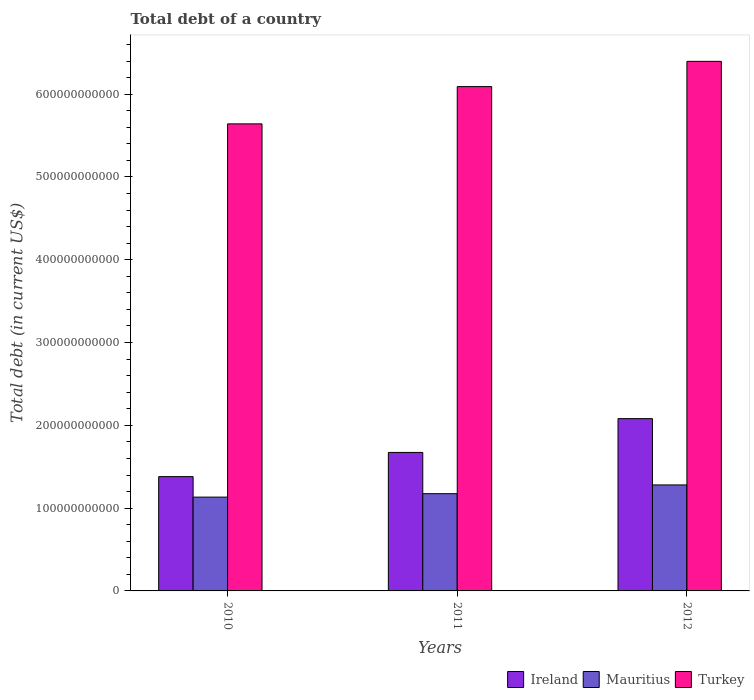How many different coloured bars are there?
Your response must be concise. 3. How many groups of bars are there?
Give a very brief answer. 3. Are the number of bars per tick equal to the number of legend labels?
Make the answer very short. Yes. What is the debt in Mauritius in 2010?
Your answer should be compact. 1.13e+11. Across all years, what is the maximum debt in Turkey?
Your answer should be compact. 6.40e+11. Across all years, what is the minimum debt in Turkey?
Make the answer very short. 5.64e+11. In which year was the debt in Mauritius maximum?
Give a very brief answer. 2012. What is the total debt in Ireland in the graph?
Make the answer very short. 5.13e+11. What is the difference between the debt in Mauritius in 2011 and that in 2012?
Keep it short and to the point. -1.06e+1. What is the difference between the debt in Ireland in 2011 and the debt in Mauritius in 2012?
Make the answer very short. 3.93e+1. What is the average debt in Turkey per year?
Your answer should be very brief. 6.04e+11. In the year 2010, what is the difference between the debt in Turkey and debt in Ireland?
Offer a terse response. 4.26e+11. In how many years, is the debt in Turkey greater than 500000000000 US$?
Provide a short and direct response. 3. What is the ratio of the debt in Turkey in 2010 to that in 2011?
Give a very brief answer. 0.93. Is the difference between the debt in Turkey in 2011 and 2012 greater than the difference between the debt in Ireland in 2011 and 2012?
Offer a terse response. Yes. What is the difference between the highest and the second highest debt in Mauritius?
Give a very brief answer. 1.06e+1. What is the difference between the highest and the lowest debt in Turkey?
Provide a short and direct response. 7.55e+1. What does the 2nd bar from the right in 2012 represents?
Ensure brevity in your answer.  Mauritius. Is it the case that in every year, the sum of the debt in Turkey and debt in Ireland is greater than the debt in Mauritius?
Make the answer very short. Yes. How many bars are there?
Give a very brief answer. 9. Are all the bars in the graph horizontal?
Your answer should be very brief. No. What is the difference between two consecutive major ticks on the Y-axis?
Your response must be concise. 1.00e+11. Are the values on the major ticks of Y-axis written in scientific E-notation?
Make the answer very short. No. Does the graph contain any zero values?
Offer a terse response. No. Where does the legend appear in the graph?
Ensure brevity in your answer.  Bottom right. How many legend labels are there?
Your response must be concise. 3. How are the legend labels stacked?
Give a very brief answer. Horizontal. What is the title of the graph?
Offer a very short reply. Total debt of a country. Does "Panama" appear as one of the legend labels in the graph?
Give a very brief answer. No. What is the label or title of the Y-axis?
Your answer should be compact. Total debt (in current US$). What is the Total debt (in current US$) in Ireland in 2010?
Ensure brevity in your answer.  1.38e+11. What is the Total debt (in current US$) of Mauritius in 2010?
Keep it short and to the point. 1.13e+11. What is the Total debt (in current US$) in Turkey in 2010?
Keep it short and to the point. 5.64e+11. What is the Total debt (in current US$) in Ireland in 2011?
Your answer should be very brief. 1.67e+11. What is the Total debt (in current US$) in Mauritius in 2011?
Ensure brevity in your answer.  1.17e+11. What is the Total debt (in current US$) in Turkey in 2011?
Your response must be concise. 6.09e+11. What is the Total debt (in current US$) in Ireland in 2012?
Keep it short and to the point. 2.08e+11. What is the Total debt (in current US$) in Mauritius in 2012?
Offer a terse response. 1.28e+11. What is the Total debt (in current US$) of Turkey in 2012?
Offer a very short reply. 6.40e+11. Across all years, what is the maximum Total debt (in current US$) of Ireland?
Make the answer very short. 2.08e+11. Across all years, what is the maximum Total debt (in current US$) of Mauritius?
Make the answer very short. 1.28e+11. Across all years, what is the maximum Total debt (in current US$) in Turkey?
Offer a terse response. 6.40e+11. Across all years, what is the minimum Total debt (in current US$) in Ireland?
Your answer should be compact. 1.38e+11. Across all years, what is the minimum Total debt (in current US$) in Mauritius?
Make the answer very short. 1.13e+11. Across all years, what is the minimum Total debt (in current US$) in Turkey?
Your answer should be compact. 5.64e+11. What is the total Total debt (in current US$) in Ireland in the graph?
Provide a succinct answer. 5.13e+11. What is the total Total debt (in current US$) of Mauritius in the graph?
Offer a terse response. 3.59e+11. What is the total Total debt (in current US$) in Turkey in the graph?
Offer a terse response. 1.81e+12. What is the difference between the Total debt (in current US$) in Ireland in 2010 and that in 2011?
Your answer should be very brief. -2.92e+1. What is the difference between the Total debt (in current US$) of Mauritius in 2010 and that in 2011?
Provide a succinct answer. -4.16e+09. What is the difference between the Total debt (in current US$) in Turkey in 2010 and that in 2011?
Keep it short and to the point. -4.50e+1. What is the difference between the Total debt (in current US$) in Ireland in 2010 and that in 2012?
Provide a short and direct response. -7.00e+1. What is the difference between the Total debt (in current US$) in Mauritius in 2010 and that in 2012?
Offer a terse response. -1.47e+1. What is the difference between the Total debt (in current US$) of Turkey in 2010 and that in 2012?
Provide a succinct answer. -7.55e+1. What is the difference between the Total debt (in current US$) of Ireland in 2011 and that in 2012?
Your response must be concise. -4.08e+1. What is the difference between the Total debt (in current US$) of Mauritius in 2011 and that in 2012?
Offer a very short reply. -1.06e+1. What is the difference between the Total debt (in current US$) of Turkey in 2011 and that in 2012?
Make the answer very short. -3.05e+1. What is the difference between the Total debt (in current US$) in Ireland in 2010 and the Total debt (in current US$) in Mauritius in 2011?
Make the answer very short. 2.06e+1. What is the difference between the Total debt (in current US$) of Ireland in 2010 and the Total debt (in current US$) of Turkey in 2011?
Provide a succinct answer. -4.71e+11. What is the difference between the Total debt (in current US$) in Mauritius in 2010 and the Total debt (in current US$) in Turkey in 2011?
Make the answer very short. -4.96e+11. What is the difference between the Total debt (in current US$) in Ireland in 2010 and the Total debt (in current US$) in Mauritius in 2012?
Give a very brief answer. 1.00e+1. What is the difference between the Total debt (in current US$) of Ireland in 2010 and the Total debt (in current US$) of Turkey in 2012?
Offer a terse response. -5.02e+11. What is the difference between the Total debt (in current US$) of Mauritius in 2010 and the Total debt (in current US$) of Turkey in 2012?
Offer a terse response. -5.26e+11. What is the difference between the Total debt (in current US$) of Ireland in 2011 and the Total debt (in current US$) of Mauritius in 2012?
Your response must be concise. 3.93e+1. What is the difference between the Total debt (in current US$) in Ireland in 2011 and the Total debt (in current US$) in Turkey in 2012?
Your answer should be very brief. -4.72e+11. What is the difference between the Total debt (in current US$) in Mauritius in 2011 and the Total debt (in current US$) in Turkey in 2012?
Provide a succinct answer. -5.22e+11. What is the average Total debt (in current US$) in Ireland per year?
Give a very brief answer. 1.71e+11. What is the average Total debt (in current US$) in Mauritius per year?
Keep it short and to the point. 1.20e+11. What is the average Total debt (in current US$) of Turkey per year?
Provide a succinct answer. 6.04e+11. In the year 2010, what is the difference between the Total debt (in current US$) of Ireland and Total debt (in current US$) of Mauritius?
Ensure brevity in your answer.  2.48e+1. In the year 2010, what is the difference between the Total debt (in current US$) of Ireland and Total debt (in current US$) of Turkey?
Ensure brevity in your answer.  -4.26e+11. In the year 2010, what is the difference between the Total debt (in current US$) of Mauritius and Total debt (in current US$) of Turkey?
Your answer should be very brief. -4.51e+11. In the year 2011, what is the difference between the Total debt (in current US$) of Ireland and Total debt (in current US$) of Mauritius?
Your response must be concise. 4.98e+1. In the year 2011, what is the difference between the Total debt (in current US$) in Ireland and Total debt (in current US$) in Turkey?
Provide a succinct answer. -4.42e+11. In the year 2011, what is the difference between the Total debt (in current US$) in Mauritius and Total debt (in current US$) in Turkey?
Provide a succinct answer. -4.92e+11. In the year 2012, what is the difference between the Total debt (in current US$) in Ireland and Total debt (in current US$) in Mauritius?
Make the answer very short. 8.01e+1. In the year 2012, what is the difference between the Total debt (in current US$) in Ireland and Total debt (in current US$) in Turkey?
Provide a short and direct response. -4.32e+11. In the year 2012, what is the difference between the Total debt (in current US$) of Mauritius and Total debt (in current US$) of Turkey?
Your answer should be compact. -5.12e+11. What is the ratio of the Total debt (in current US$) of Ireland in 2010 to that in 2011?
Offer a very short reply. 0.83. What is the ratio of the Total debt (in current US$) in Mauritius in 2010 to that in 2011?
Provide a succinct answer. 0.96. What is the ratio of the Total debt (in current US$) in Turkey in 2010 to that in 2011?
Give a very brief answer. 0.93. What is the ratio of the Total debt (in current US$) in Ireland in 2010 to that in 2012?
Offer a terse response. 0.66. What is the ratio of the Total debt (in current US$) in Mauritius in 2010 to that in 2012?
Provide a succinct answer. 0.89. What is the ratio of the Total debt (in current US$) of Turkey in 2010 to that in 2012?
Offer a very short reply. 0.88. What is the ratio of the Total debt (in current US$) in Ireland in 2011 to that in 2012?
Provide a succinct answer. 0.8. What is the ratio of the Total debt (in current US$) in Mauritius in 2011 to that in 2012?
Offer a terse response. 0.92. What is the ratio of the Total debt (in current US$) in Turkey in 2011 to that in 2012?
Offer a very short reply. 0.95. What is the difference between the highest and the second highest Total debt (in current US$) in Ireland?
Make the answer very short. 4.08e+1. What is the difference between the highest and the second highest Total debt (in current US$) in Mauritius?
Ensure brevity in your answer.  1.06e+1. What is the difference between the highest and the second highest Total debt (in current US$) in Turkey?
Ensure brevity in your answer.  3.05e+1. What is the difference between the highest and the lowest Total debt (in current US$) of Ireland?
Ensure brevity in your answer.  7.00e+1. What is the difference between the highest and the lowest Total debt (in current US$) of Mauritius?
Keep it short and to the point. 1.47e+1. What is the difference between the highest and the lowest Total debt (in current US$) in Turkey?
Provide a short and direct response. 7.55e+1. 